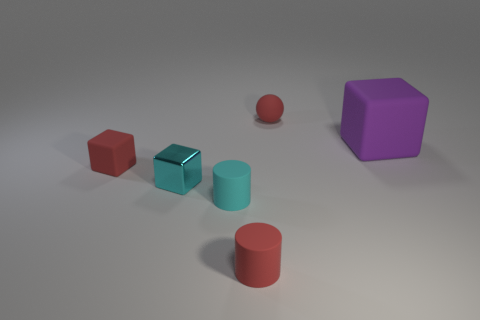There is a rubber block that is left of the red matte thing that is behind the cube to the right of the small cyan cube; how big is it?
Offer a terse response. Small. What is the size of the other thing that is the same shape as the small cyan rubber thing?
Offer a very short reply. Small. How many large things are red things or red spheres?
Your answer should be very brief. 0. Is the tiny cylinder behind the red cylinder made of the same material as the small red object that is behind the tiny rubber block?
Your answer should be compact. Yes. There is a block that is to the right of the red ball; what is its material?
Your answer should be very brief. Rubber. What number of shiny objects are either big things or tiny red things?
Offer a terse response. 0. What color is the thing that is to the right of the tiny object that is behind the large object?
Your answer should be compact. Purple. Does the purple cube have the same material as the small red thing behind the big purple thing?
Provide a short and direct response. Yes. There is a matte block on the left side of the block right of the tiny red thing behind the red matte cube; what is its color?
Give a very brief answer. Red. Are there any other things that have the same shape as the large rubber thing?
Your answer should be compact. Yes. 